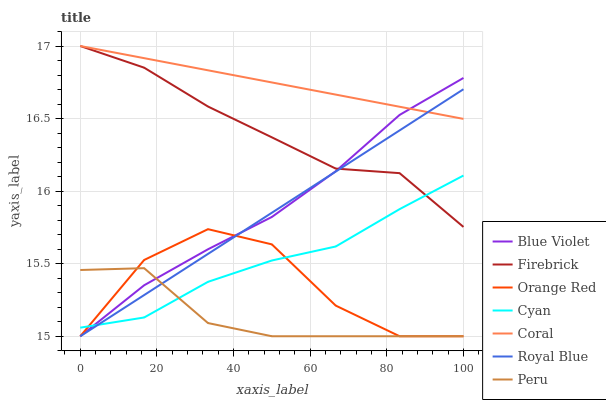Does Peru have the minimum area under the curve?
Answer yes or no. Yes. Does Coral have the maximum area under the curve?
Answer yes or no. Yes. Does Orange Red have the minimum area under the curve?
Answer yes or no. No. Does Orange Red have the maximum area under the curve?
Answer yes or no. No. Is Royal Blue the smoothest?
Answer yes or no. Yes. Is Orange Red the roughest?
Answer yes or no. Yes. Is Orange Red the smoothest?
Answer yes or no. No. Is Royal Blue the roughest?
Answer yes or no. No. Does Orange Red have the lowest value?
Answer yes or no. Yes. Does Cyan have the lowest value?
Answer yes or no. No. Does Firebrick have the highest value?
Answer yes or no. Yes. Does Orange Red have the highest value?
Answer yes or no. No. Is Cyan less than Coral?
Answer yes or no. Yes. Is Coral greater than Orange Red?
Answer yes or no. Yes. Does Cyan intersect Royal Blue?
Answer yes or no. Yes. Is Cyan less than Royal Blue?
Answer yes or no. No. Is Cyan greater than Royal Blue?
Answer yes or no. No. Does Cyan intersect Coral?
Answer yes or no. No. 